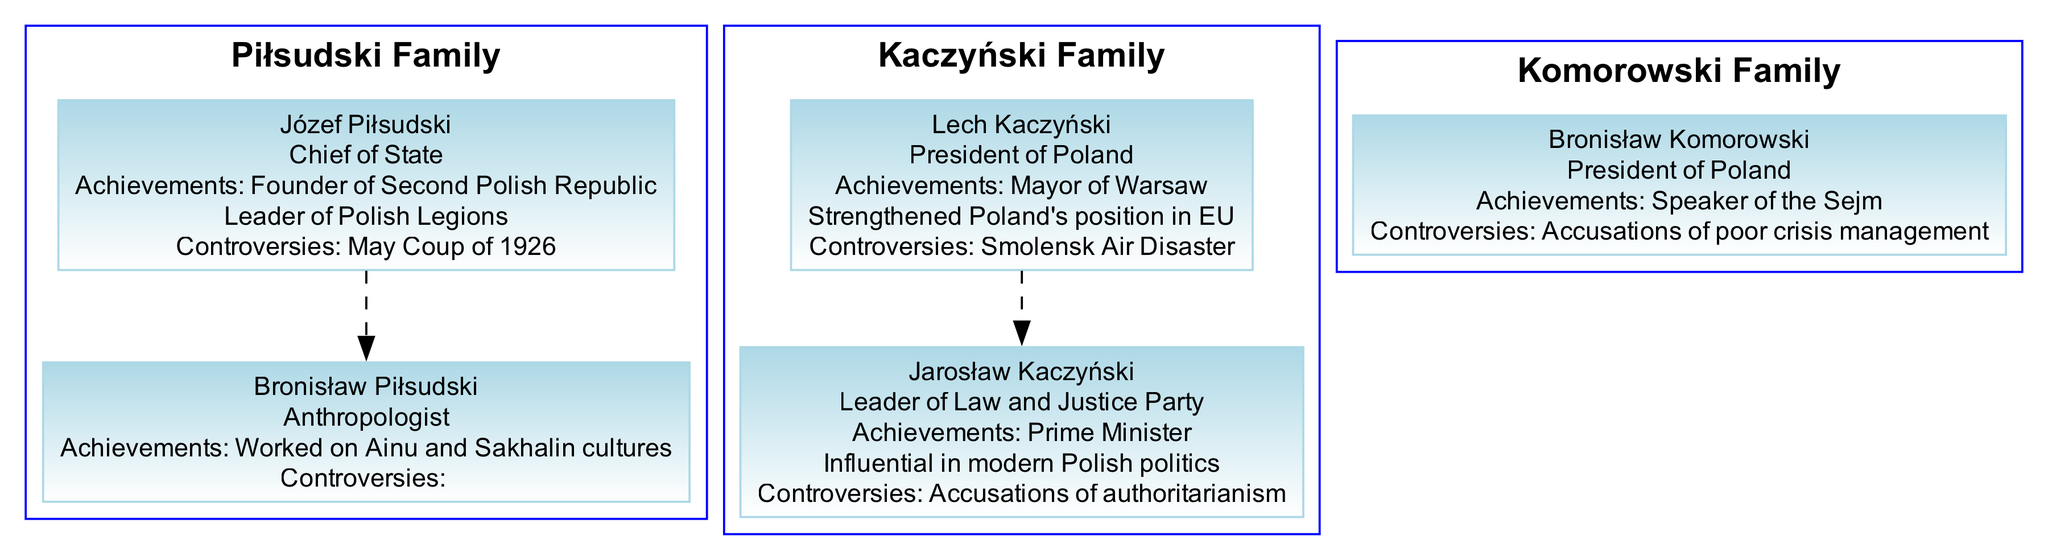What are the two main political family dynasties depicted in the diagram? The diagram shows the Piłsudski Family and the Kaczyński Family as the two primary political dynasties. Both families have significant historical impact in Polish politics.
Answer: Piłsudski Family, Kaczyński Family Who is the member known for the May Coup of 1926? Józef Piłsudski is the member associated with the May Coup of 1926, which is listed as one of his controversies in the diagram.
Answer: Józef Piłsudski How many members are there in the Kaczyński Family? The Kaczyński Family has two members, Lech Kaczyński and Jarosław Kaczyński, as indicated under this family segment in the diagram.
Answer: 2 Which family does Bronisław Komorowski belong to? Bronisław Komorowski is listed under the Komorowski Family in the diagram, with details about his role as President.
Answer: Komorowski Family What achievement is associated with Lech Kaczyński? Lech Kaczyński is recognized for strengthening Poland’s position in the European Union, highlighting one of his notable achievements in the diagram.
Answer: Strengthened Poland's position in EU Which member of the Piłsudski Family was an anthropologist? Bronisław Piłsudski is identified as the anthropologist within the Piłsudski Family in the diagram, contrasting with his more politically active relative.
Answer: Bronisław Piłsudski What was one major controversy tied to Jarosław Kaczyński? Jarosław Kaczyński has accusations of authoritarianism listed as one of his controversies within the diagram, illustrating a contentious aspect of his political career.
Answer: Accusations of authoritarianism In which family tree section is the title "Chief of State" found? The title "Chief of State" is found in the Piłsudski Family section of the diagram, specifically associated with Józef Piłsudski.
Answer: Piłsudski Family Which political figure is highlighted for promoting democratic reforms? Tadeusz Mazowiecki is the figure noted for promoting democratic reforms, depicting a significant contribution to Poland’s civil liberties through his actions as Prime Minister.
Answer: Tadeusz Mazowiecki 